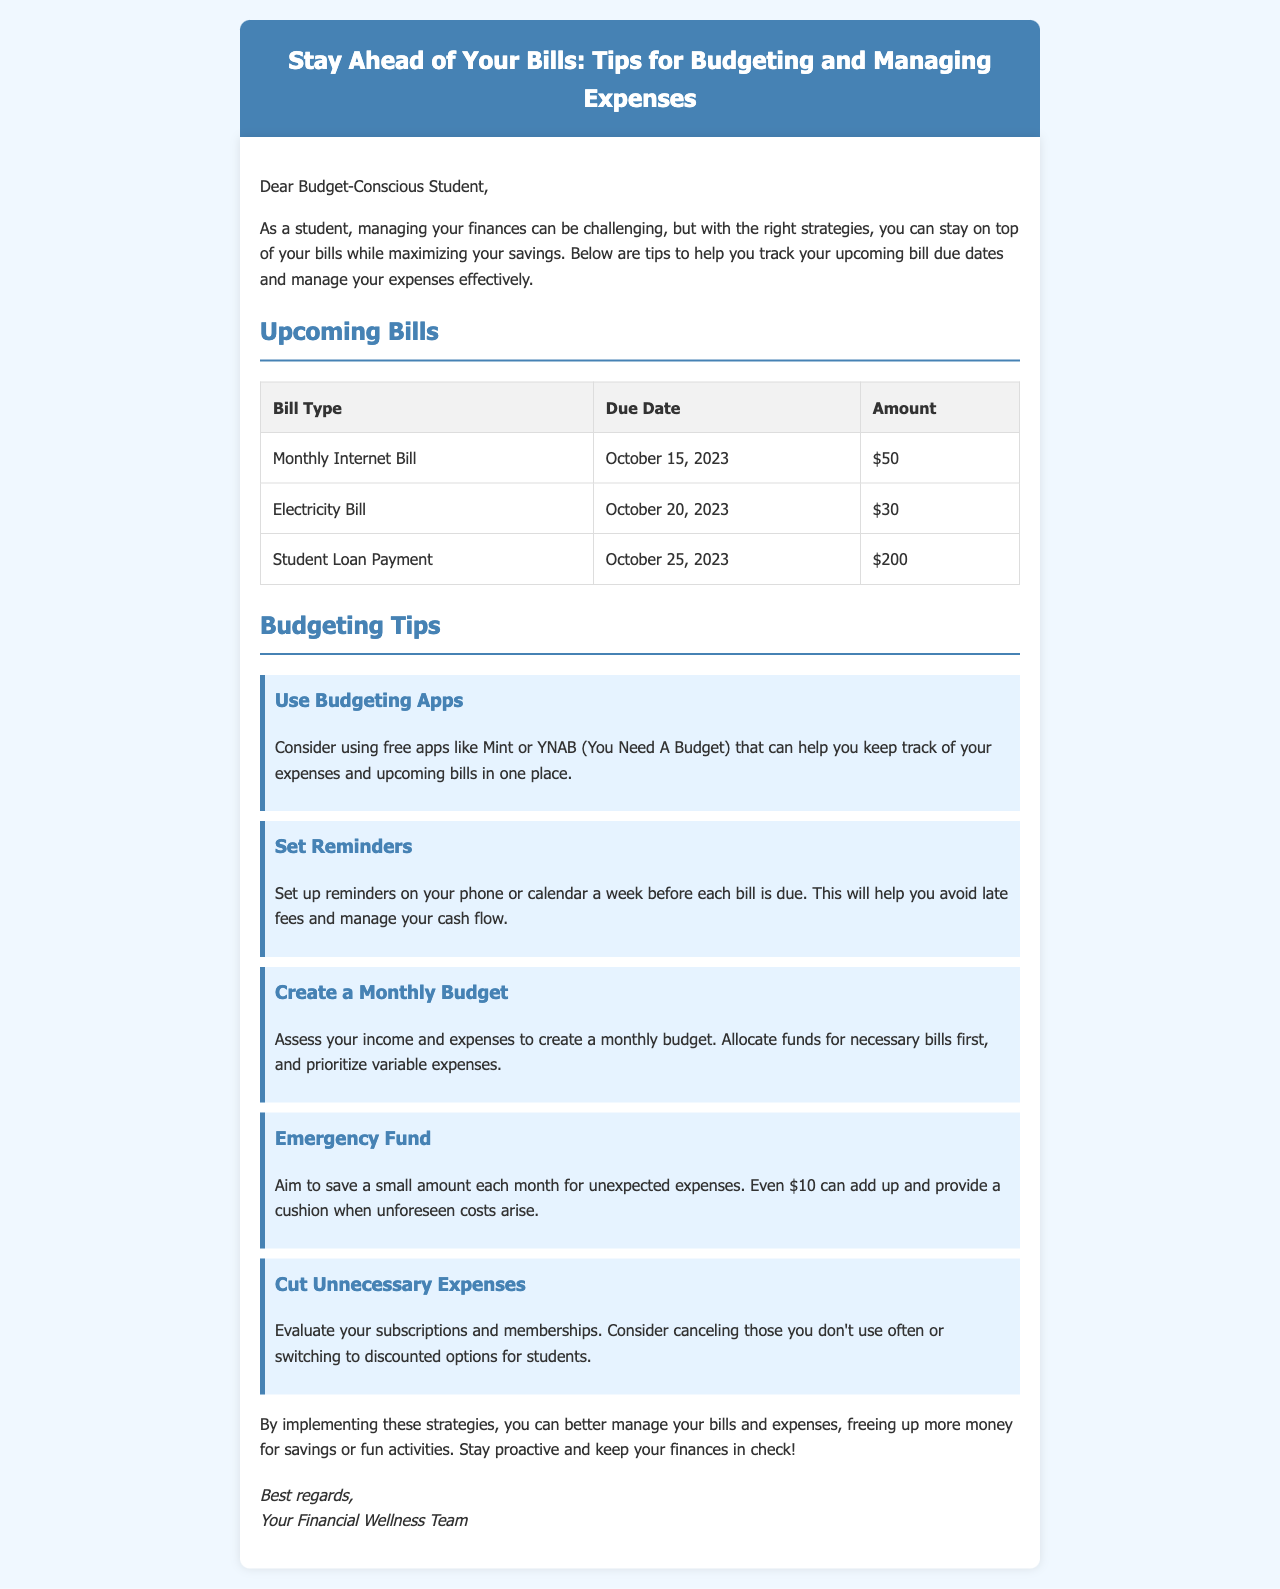what is the due date for the Monthly Internet Bill? The due date for the Monthly Internet Bill can be found in the Upcoming Bills section of the document, which is October 15, 2023.
Answer: October 15, 2023 how much is the Electricity Bill? The amount for the Electricity Bill is listed in the table under the Amount column, which states $30.
Answer: $30 what budgeting app is suggested in the tips? The document mentions using free apps, particularly Mint and YNAB, to help with budgeting.
Answer: Mint or YNAB how many tips for budgeting are provided in the document? There are five distinct budgeting tips listed in the Budgeting Tips section of the document.
Answer: Five what should you do a week before each bill is due? The document advises setting up reminders on your phone or calendar a week before each bill is due to manage cash flow.
Answer: Set up reminders what is the suggested amount to save for an emergency fund? The text states that even $10 set aside monthly can create a cushion for unexpected expenses.
Answer: $10 what is the main goal of the mail? The primary goal of the mail is to help students manage their bills and expenses effectively while maximizing savings.
Answer: Stay ahead of your bills which team signed off the document? The document concludes with a signature from "Your Financial Wellness Team."
Answer: Your Financial Wellness Team 